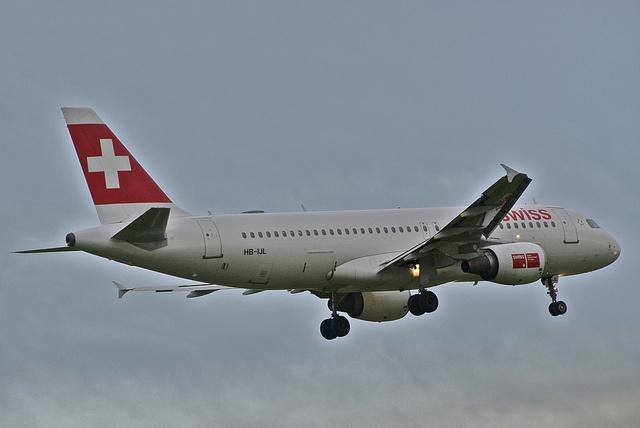Describe the objects in this image and their specific colors. I can see a airplane in gray, darkgray, black, and maroon tones in this image. 